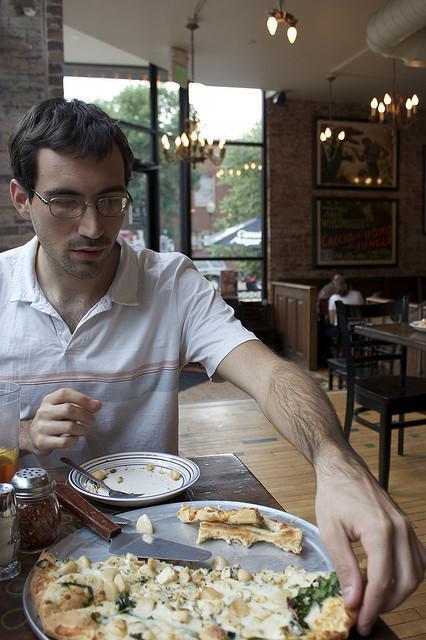How many pizzas can you see?
Give a very brief answer. 1. 